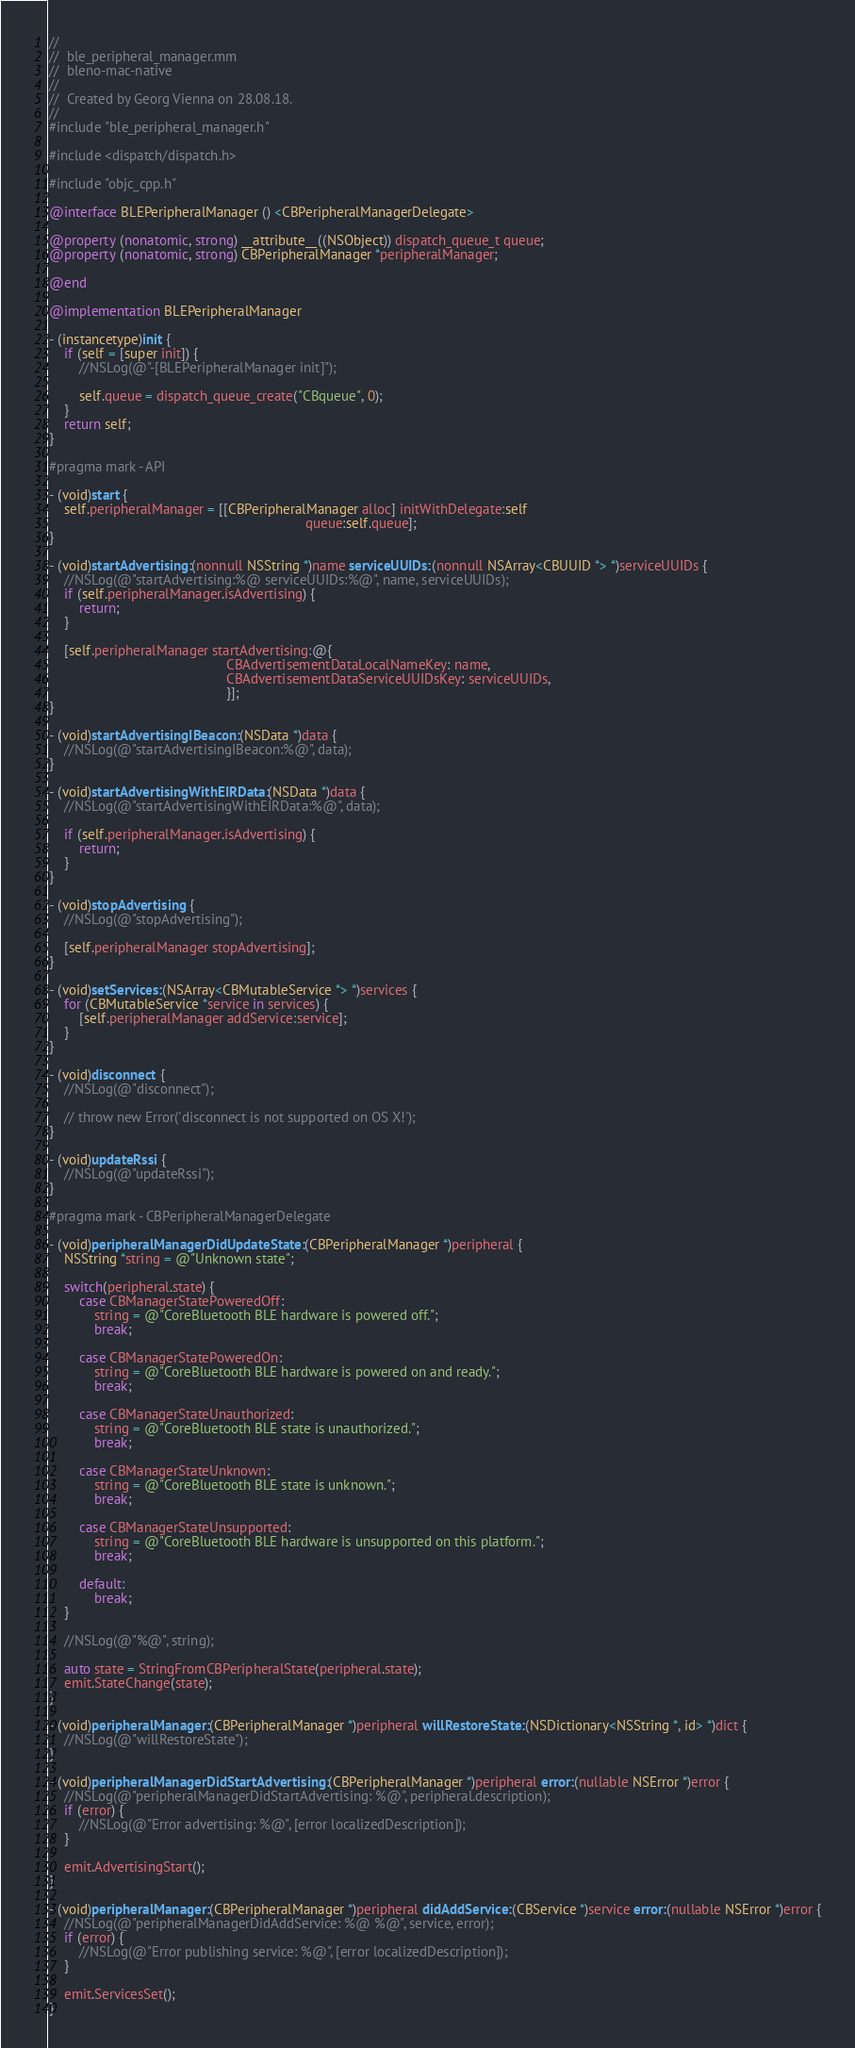Convert code to text. <code><loc_0><loc_0><loc_500><loc_500><_ObjectiveC_>//
//  ble_peripheral_manager.mm
//  bleno-mac-native
//
//  Created by Georg Vienna on 28.08.18.
//
#include "ble_peripheral_manager.h"

#include <dispatch/dispatch.h>

#include "objc_cpp.h"

@interface BLEPeripheralManager () <CBPeripheralManagerDelegate>

@property (nonatomic, strong) __attribute__((NSObject)) dispatch_queue_t queue;
@property (nonatomic, strong) CBPeripheralManager *peripheralManager;

@end

@implementation BLEPeripheralManager

- (instancetype)init {
    if (self = [super init]) {
        //NSLog(@"-[BLEPeripheralManager init]");

        self.queue = dispatch_queue_create("CBqueue", 0);
    }
    return self;
}

#pragma mark - API

- (void)start {
    self.peripheralManager = [[CBPeripheralManager alloc] initWithDelegate:self
                                                                    queue:self.queue];
}

- (void)startAdvertising:(nonnull NSString *)name serviceUUIDs:(nonnull NSArray<CBUUID *> *)serviceUUIDs {
    //NSLog(@"startAdvertising:%@ serviceUUIDs:%@", name, serviceUUIDs);
    if (self.peripheralManager.isAdvertising) {
        return;
    }

    [self.peripheralManager startAdvertising:@{
                                               CBAdvertisementDataLocalNameKey: name,
                                               CBAdvertisementDataServiceUUIDsKey: serviceUUIDs,
                                               }];
}

- (void)startAdvertisingIBeacon:(NSData *)data {
    //NSLog(@"startAdvertisingIBeacon:%@", data);
}

- (void)startAdvertisingWithEIRData:(NSData *)data {
    //NSLog(@"startAdvertisingWithEIRData:%@", data);

    if (self.peripheralManager.isAdvertising) {
        return;
    }
}

- (void)stopAdvertising {
    //NSLog(@"stopAdvertising");

    [self.peripheralManager stopAdvertising];
}

- (void)setServices:(NSArray<CBMutableService *> *)services {
    for (CBMutableService *service in services) {
        [self.peripheralManager addService:service];
    }
}

- (void)disconnect {
    //NSLog(@"disconnect");

    // throw new Error('disconnect is not supported on OS X!');
}

- (void)updateRssi {
    //NSLog(@"updateRssi");
}

#pragma mark - CBPeripheralManagerDelegate

- (void)peripheralManagerDidUpdateState:(CBPeripheralManager *)peripheral {
    NSString *string = @"Unknown state";

    switch(peripheral.state) {
        case CBManagerStatePoweredOff:
            string = @"CoreBluetooth BLE hardware is powered off.";
            break;

        case CBManagerStatePoweredOn:
            string = @"CoreBluetooth BLE hardware is powered on and ready.";
            break;

        case CBManagerStateUnauthorized:
            string = @"CoreBluetooth BLE state is unauthorized.";
            break;

        case CBManagerStateUnknown:
            string = @"CoreBluetooth BLE state is unknown.";
            break;

        case CBManagerStateUnsupported:
            string = @"CoreBluetooth BLE hardware is unsupported on this platform.";
            break;

        default:
            break;
    }

    //NSLog(@"%@", string);

    auto state = StringFromCBPeripheralState(peripheral.state);
    emit.StateChange(state);
}

- (void)peripheralManager:(CBPeripheralManager *)peripheral willRestoreState:(NSDictionary<NSString *, id> *)dict {
    //NSLog(@"willRestoreState");
}

- (void)peripheralManagerDidStartAdvertising:(CBPeripheralManager *)peripheral error:(nullable NSError *)error {
    //NSLog(@"peripheralManagerDidStartAdvertising: %@", peripheral.description);
    if (error) {
        //NSLog(@"Error advertising: %@", [error localizedDescription]);
    }

    emit.AdvertisingStart();
}

- (void)peripheralManager:(CBPeripheralManager *)peripheral didAddService:(CBService *)service error:(nullable NSError *)error {
    //NSLog(@"peripheralManagerDidAddService: %@ %@", service, error);
    if (error) {
        //NSLog(@"Error publishing service: %@", [error localizedDescription]);
    }

    emit.ServicesSet();
}
</code> 